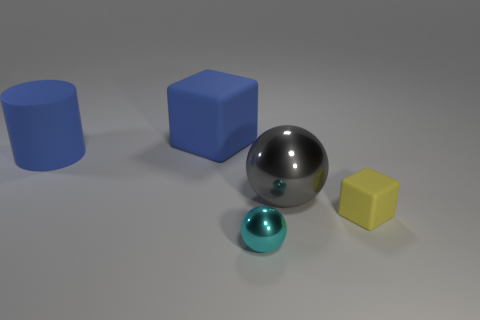Add 4 small yellow things. How many objects exist? 9 Subtract all spheres. How many objects are left? 3 Subtract 0 cyan blocks. How many objects are left? 5 Subtract all tiny shiny balls. Subtract all big blue cylinders. How many objects are left? 3 Add 5 tiny cyan spheres. How many tiny cyan spheres are left? 6 Add 2 big rubber blocks. How many big rubber blocks exist? 3 